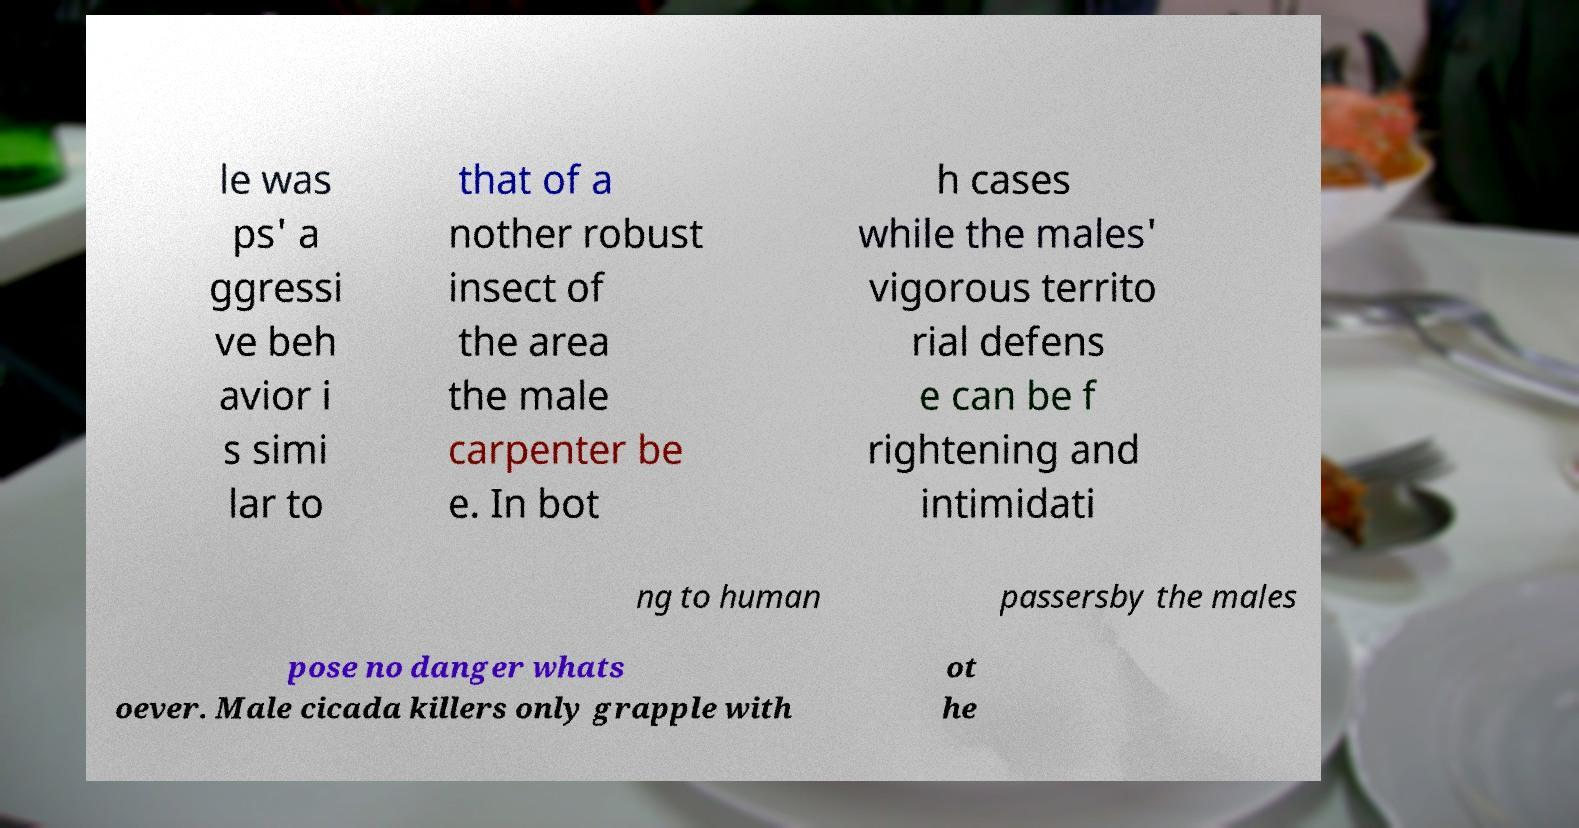For documentation purposes, I need the text within this image transcribed. Could you provide that? le was ps' a ggressi ve beh avior i s simi lar to that of a nother robust insect of the area the male carpenter be e. In bot h cases while the males' vigorous territo rial defens e can be f rightening and intimidati ng to human passersby the males pose no danger whats oever. Male cicada killers only grapple with ot he 